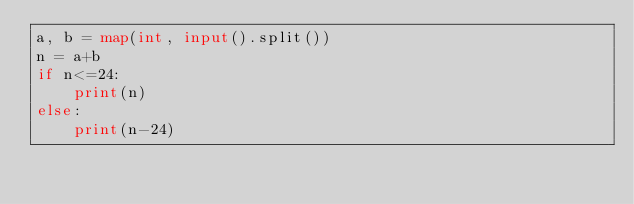<code> <loc_0><loc_0><loc_500><loc_500><_Python_>a, b = map(int, input().split())
n = a+b
if n<=24:
    print(n)
else:
    print(n-24)</code> 